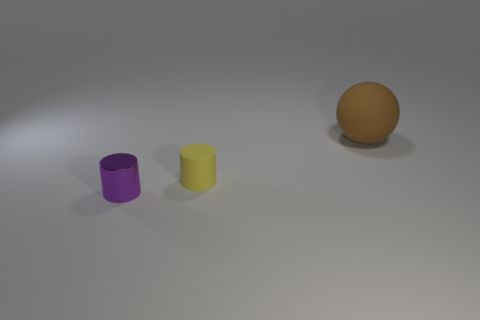How many other things are made of the same material as the yellow cylinder?
Your answer should be very brief. 1. There is a small purple metallic object that is in front of the yellow matte object; is its shape the same as the brown thing?
Provide a short and direct response. No. Is there a tiny green rubber thing?
Your answer should be very brief. No. Are there any other things that are the same shape as the big brown thing?
Provide a short and direct response. No. Are there more rubber balls behind the small purple cylinder than big blue things?
Keep it short and to the point. Yes. Are there any purple cylinders in front of the brown sphere?
Ensure brevity in your answer.  Yes. Does the yellow matte cylinder have the same size as the purple cylinder?
Make the answer very short. Yes. What is the size of the shiny object that is the same shape as the small yellow matte object?
Your answer should be very brief. Small. Is there anything else that is the same size as the purple object?
Keep it short and to the point. Yes. What material is the tiny cylinder left of the matte thing in front of the large brown sphere made of?
Make the answer very short. Metal. 